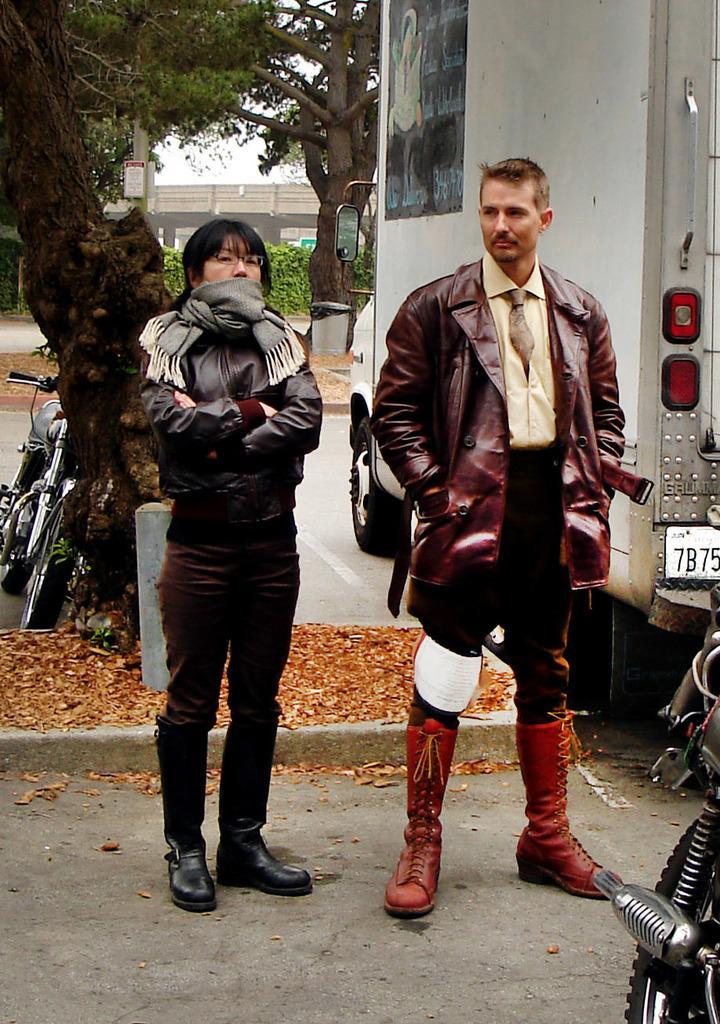In one or two sentences, can you explain what this image depicts? In this image I can see two persons standing one man and a woman and trees and a bridge behind them and a truck in the top right corner and a bike in the bottom right corner and another bike on the left side of the image. 